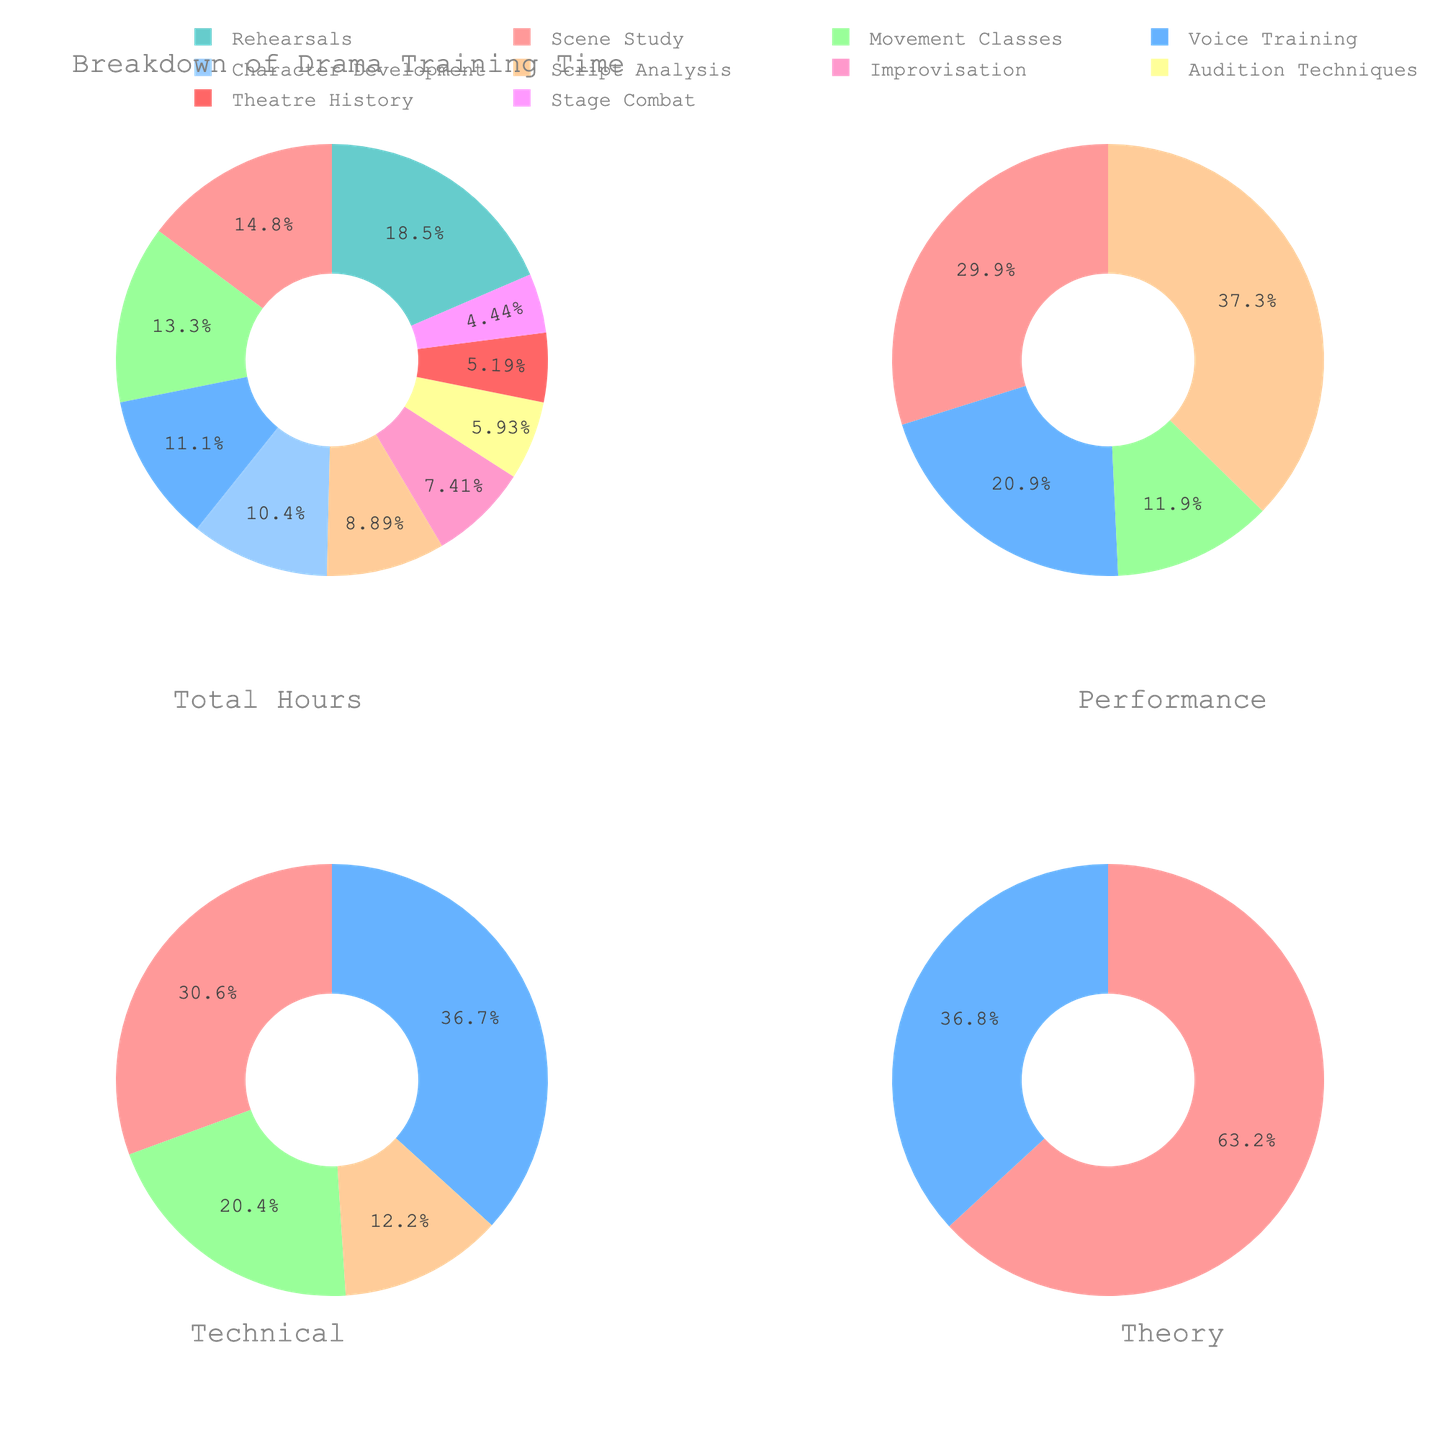What is the title of the figure? The title of the figure is usually displayed at the top of the figure. The title helps readers understand what the figure is about at a glance.
Answer: Breakdown of Drama Training Time Which category has the largest share in the "Overview" pie chart? In the "Overview" pie chart, look for the segment with the greatest size visually and check its associated label. This category represents the largest share of time spent.
Answer: Rehearsals How many hours are spent on "Scene Study" and "Rehearsals" combined? Identify the hours listed for "Scene Study" and "Rehearsals" in the data set and then sum them together: 20 (Scene Study) + 25 (Rehearsals).
Answer: 45 Which sub-category occupies the most time in the "Performance Preparation" pie chart? Examine the "Performance Preparation" pie chart. Look for the section that visually appears to occupy the most space and locate its label.
Answer: Rehearsals What percentage of the total time is spent on "Character Development" in the "Technical Skills" pie chart? First observe that "Character Development" is not part of "Technical Skills". Check the "Technical Skills" pie chart and note that "Character Development" is excluded from it.
Answer: 0% How does the time spent on "Voice Training" compare to the time spent on "Improvisation"? Compare the size of the slices for "Voice Training" and "Improvisation" in the "Technical Skills" pie chart or refer to their corresponding hours in the data: 15 (Voice Training) vs. 10 (Improvisation).
Answer: Voice Training is greater Which pie chart has the smallest number of categories? Out of the four pie charts, identify the one with the fewest segments/categories. Check the "Theoretical Knowledge" pie chart, containing Script Analysis and Theatre History.
Answer: Theoretical Knowledge What is the combined percentage of "Script Analysis" and "Theatre History" in the total drama training? Add the hours for "Script Analysis" and "Theatre History" and divide by the total hours, then convert to a percentage: (12 + 7) / 135 * 100.
Answer: 14.07% What is the difference in the number of hours spent on "Stage Combat" and "Theatre History"? Subtract the hours for "Theatre History" from the hours for "Stage Combat" using the data provided: 6 (Stage Combat) - 7 (Theatre History).
Answer: -1 Which category contributes the most to the "Technical Skills" pie chart? Look at the "Technical Skills" pie chart and identify the largest segment visually, then check its label.
Answer: Movement Classes 